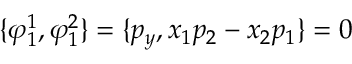<formula> <loc_0><loc_0><loc_500><loc_500>\{ \varphi _ { 1 } ^ { 1 } , \varphi _ { 1 } ^ { 2 } \} = \{ p _ { y } , x _ { 1 } p _ { 2 } - x _ { 2 } p _ { 1 } \} = 0</formula> 